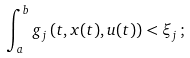<formula> <loc_0><loc_0><loc_500><loc_500>\int _ { a } ^ { b } g _ { j } \left ( t , x ( t ) , u ( t ) \right ) < \xi _ { j } \, ;</formula> 